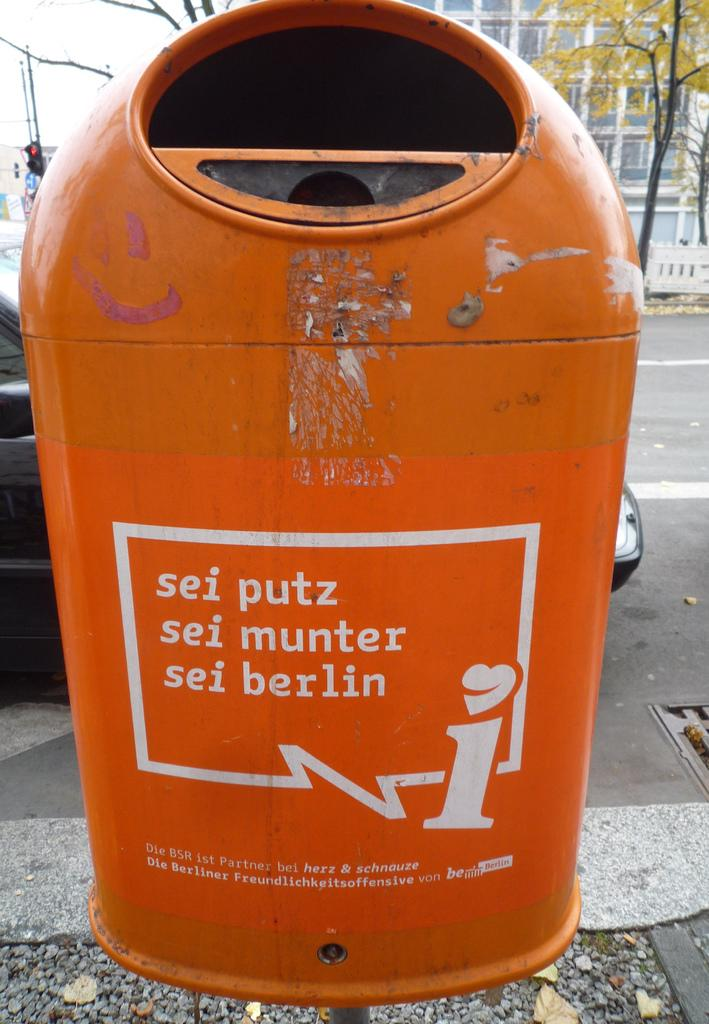Provide a one-sentence caption for the provided image. A recycling bin sits on a sidewalk in Berlin. 